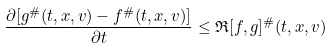<formula> <loc_0><loc_0><loc_500><loc_500>\frac { \partial [ g ^ { \# } ( t , x , v ) - f ^ { \# } ( t , x , v ) ] } { \partial t } \leq \mathfrak { R } [ f , g ] ^ { \# } ( t , x , v )</formula> 